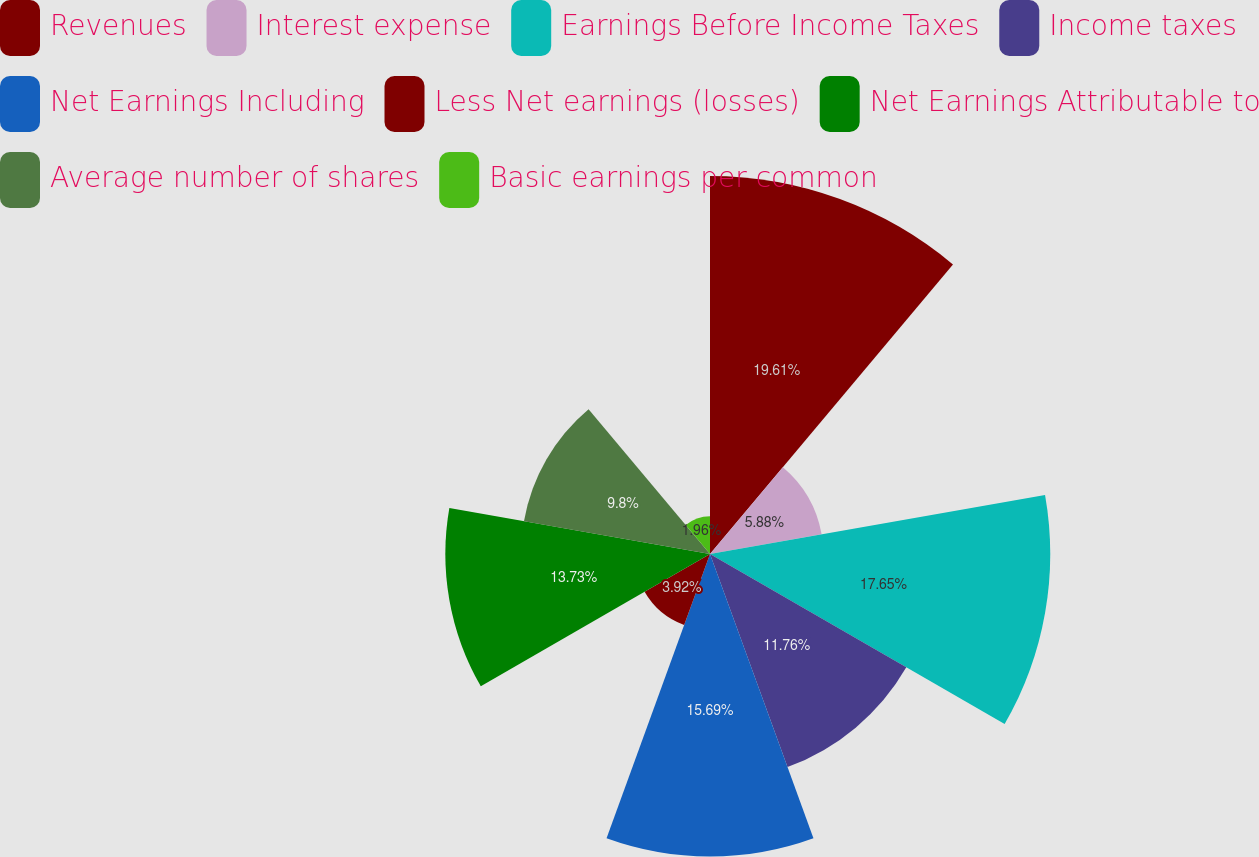<chart> <loc_0><loc_0><loc_500><loc_500><pie_chart><fcel>Revenues<fcel>Interest expense<fcel>Earnings Before Income Taxes<fcel>Income taxes<fcel>Net Earnings Including<fcel>Less Net earnings (losses)<fcel>Net Earnings Attributable to<fcel>Average number of shares<fcel>Basic earnings per common<nl><fcel>19.61%<fcel>5.88%<fcel>17.65%<fcel>11.76%<fcel>15.69%<fcel>3.92%<fcel>13.73%<fcel>9.8%<fcel>1.96%<nl></chart> 